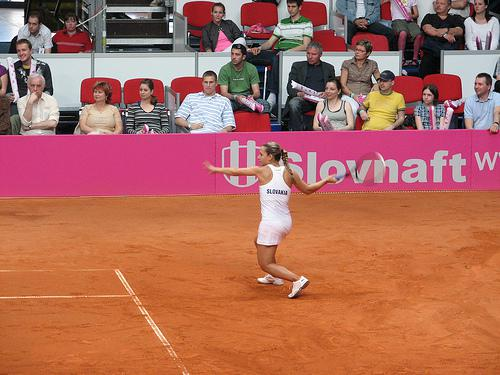Question: what kind of shoes is the woman wearing?
Choices:
A. Sneakers.
B. Sandals.
C. Flip flops.
D. Slippers.
Answer with the letter. Answer: A Question: what sport is this?
Choices:
A. Baseball.
B. Basketball.
C. Tennis.
D. Hockey.
Answer with the letter. Answer: C Question: where is this sport being played?
Choices:
A. Tennis court.
B. Football field.
C. Basketball court.
D. Bowling alley.
Answer with the letter. Answer: A Question: where is this taking place?
Choices:
A. A game.
B. On a tennis court.
C. A play.
D. The Beach.
Answer with the letter. Answer: B 